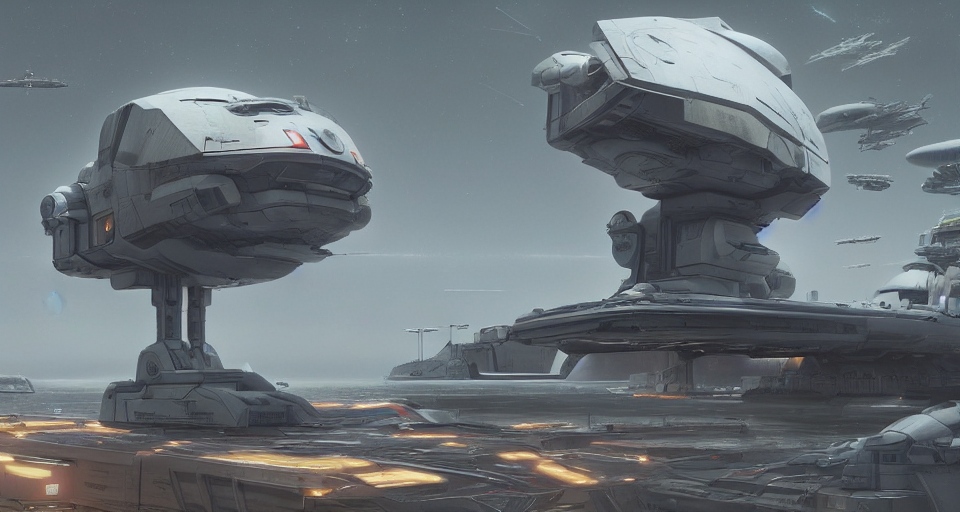What kind of environment does this scene depict? The image illustrates a futuristic industrial environment, likely a spaceport or docking station for spacecraft, characterized by its metallic structures and advanced vehicles. 